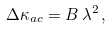<formula> <loc_0><loc_0><loc_500><loc_500>\Delta \kappa _ { a c } = B \, \lambda ^ { 2 } \, ,</formula> 